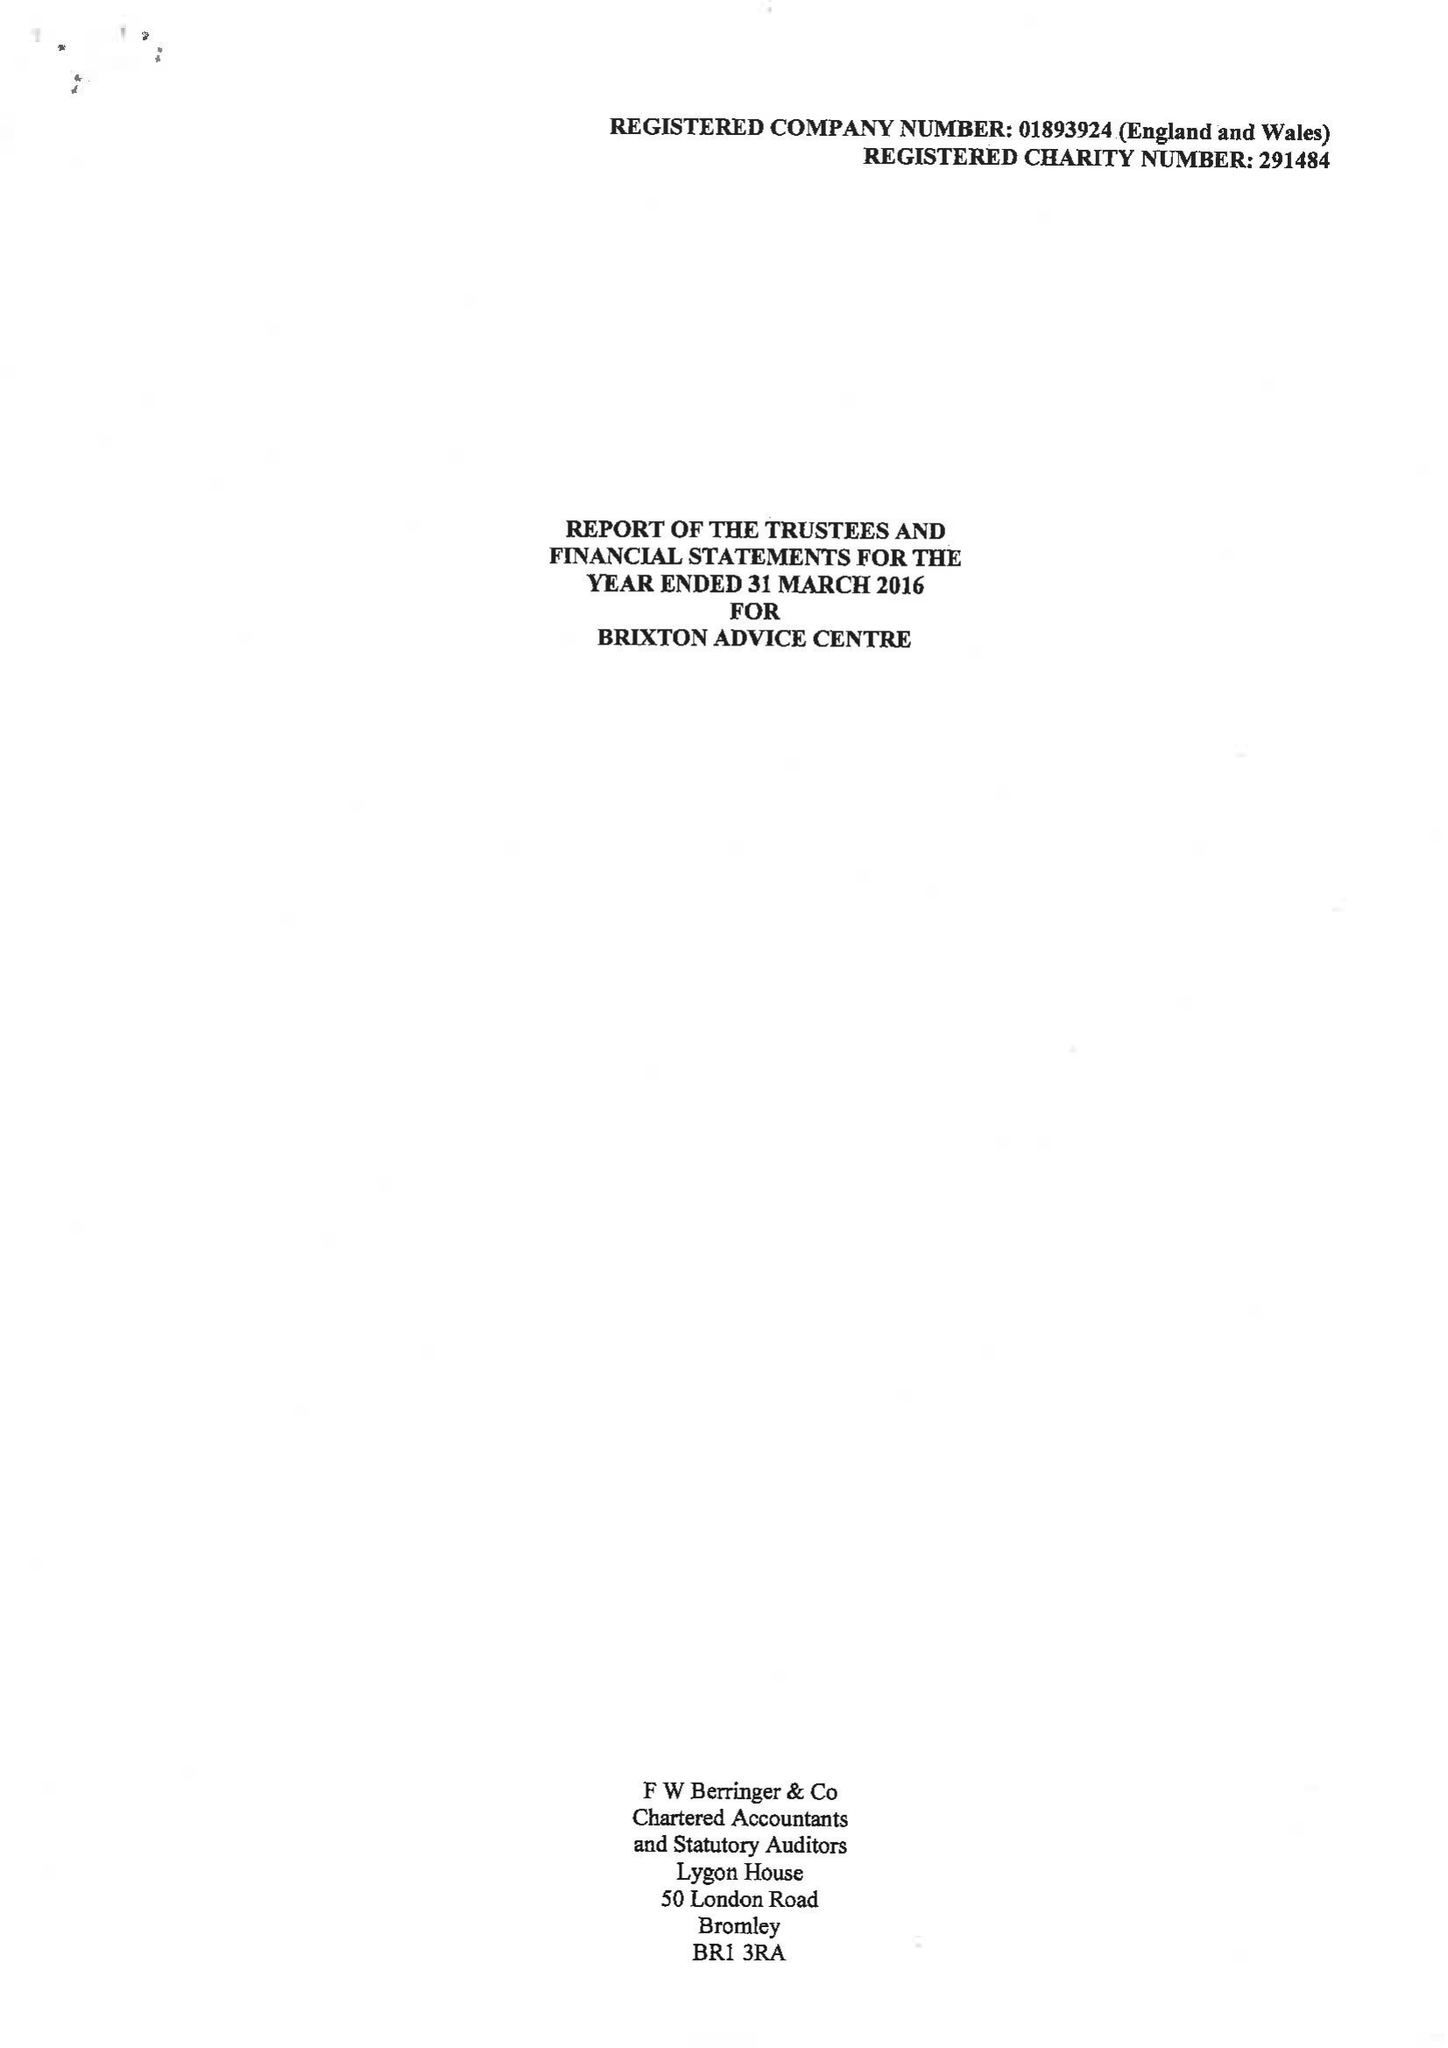What is the value for the charity_name?
Answer the question using a single word or phrase. Brixton Advice Centre 